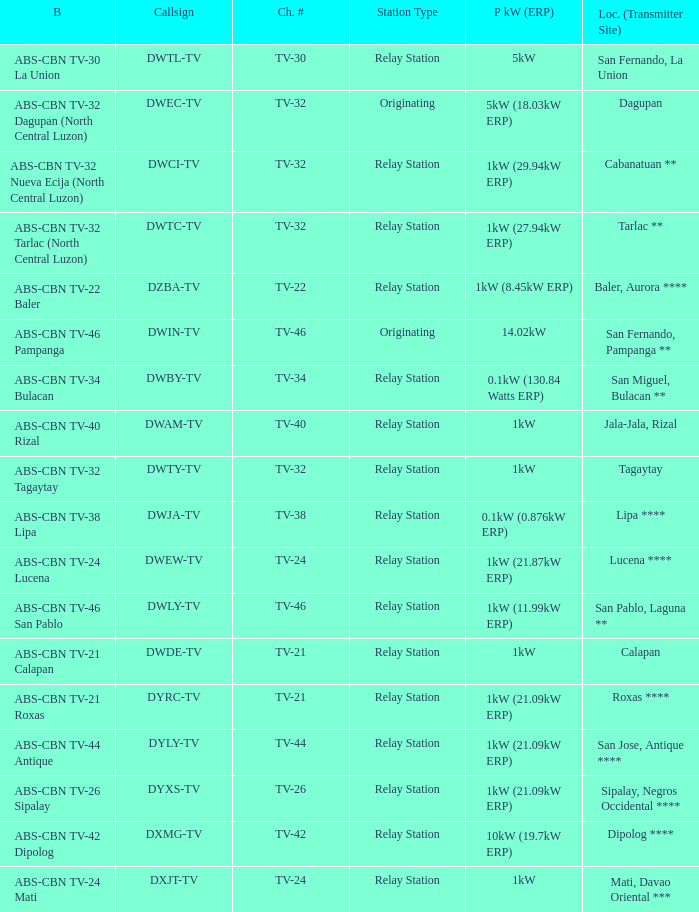The callsign DWEC-TV has what branding?  ABS-CBN TV-32 Dagupan (North Central Luzon). 